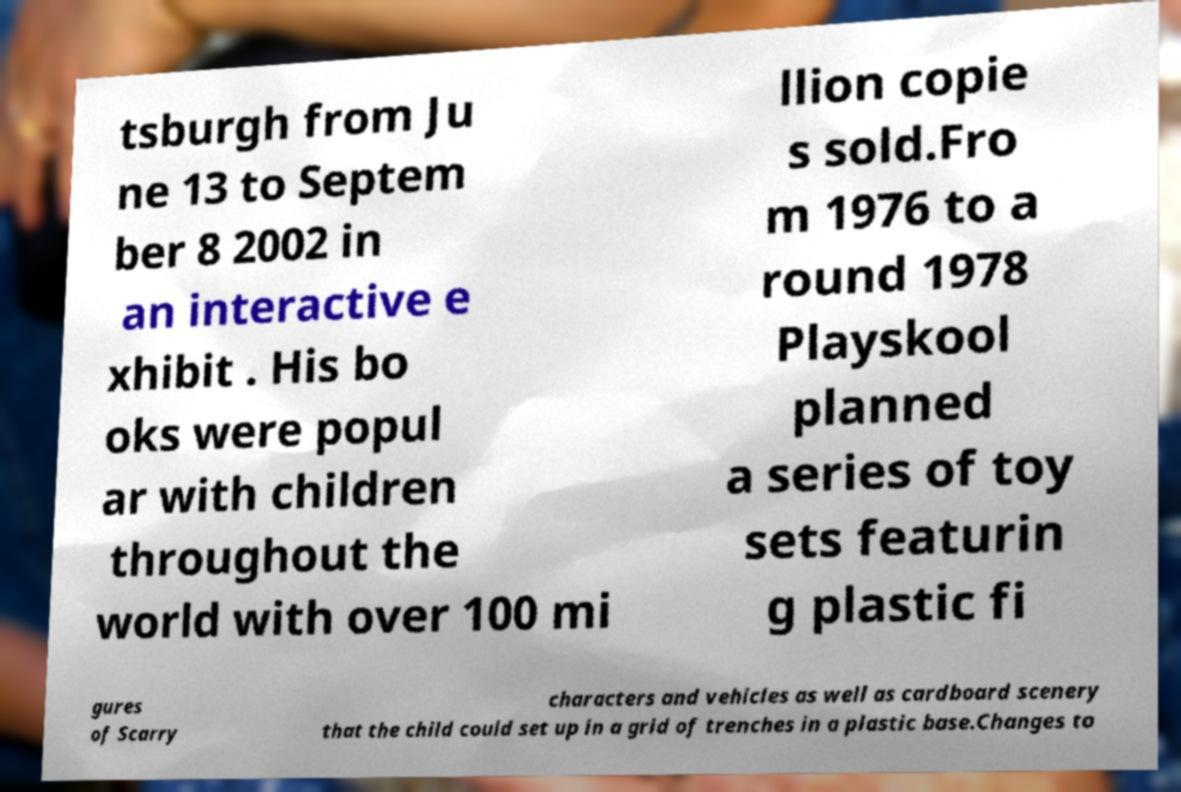There's text embedded in this image that I need extracted. Can you transcribe it verbatim? tsburgh from Ju ne 13 to Septem ber 8 2002 in an interactive e xhibit . His bo oks were popul ar with children throughout the world with over 100 mi llion copie s sold.Fro m 1976 to a round 1978 Playskool planned a series of toy sets featurin g plastic fi gures of Scarry characters and vehicles as well as cardboard scenery that the child could set up in a grid of trenches in a plastic base.Changes to 